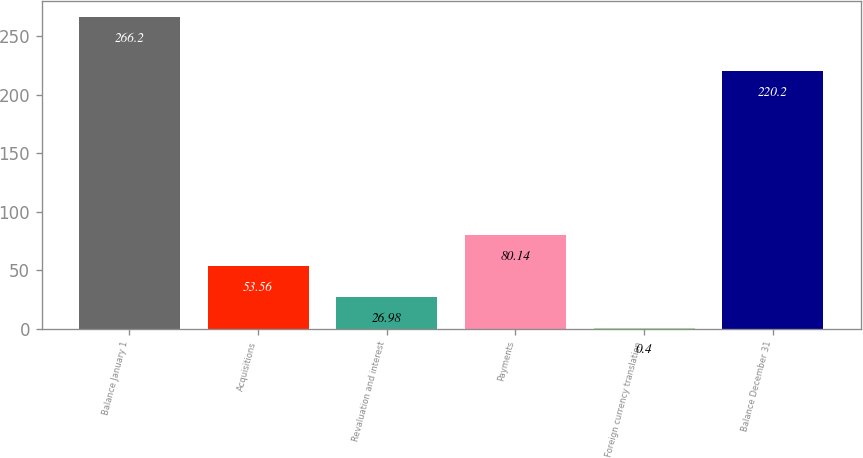Convert chart to OTSL. <chart><loc_0><loc_0><loc_500><loc_500><bar_chart><fcel>Balance January 1<fcel>Acquisitions<fcel>Revaluation and interest<fcel>Payments<fcel>Foreign currency translation<fcel>Balance December 31<nl><fcel>266.2<fcel>53.56<fcel>26.98<fcel>80.14<fcel>0.4<fcel>220.2<nl></chart> 